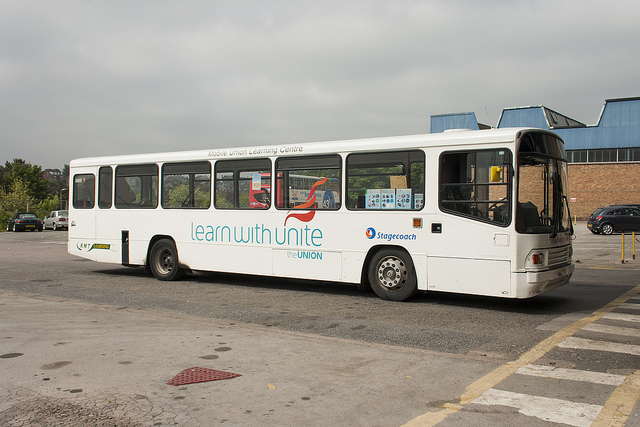Identify the text displayed in this image. learn with Unite UNION Stagecoach 